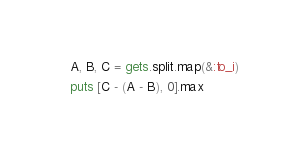Convert code to text. <code><loc_0><loc_0><loc_500><loc_500><_Ruby_>A, B, C = gets.split.map(&:to_i)

puts [C - (A - B), 0].max
</code> 